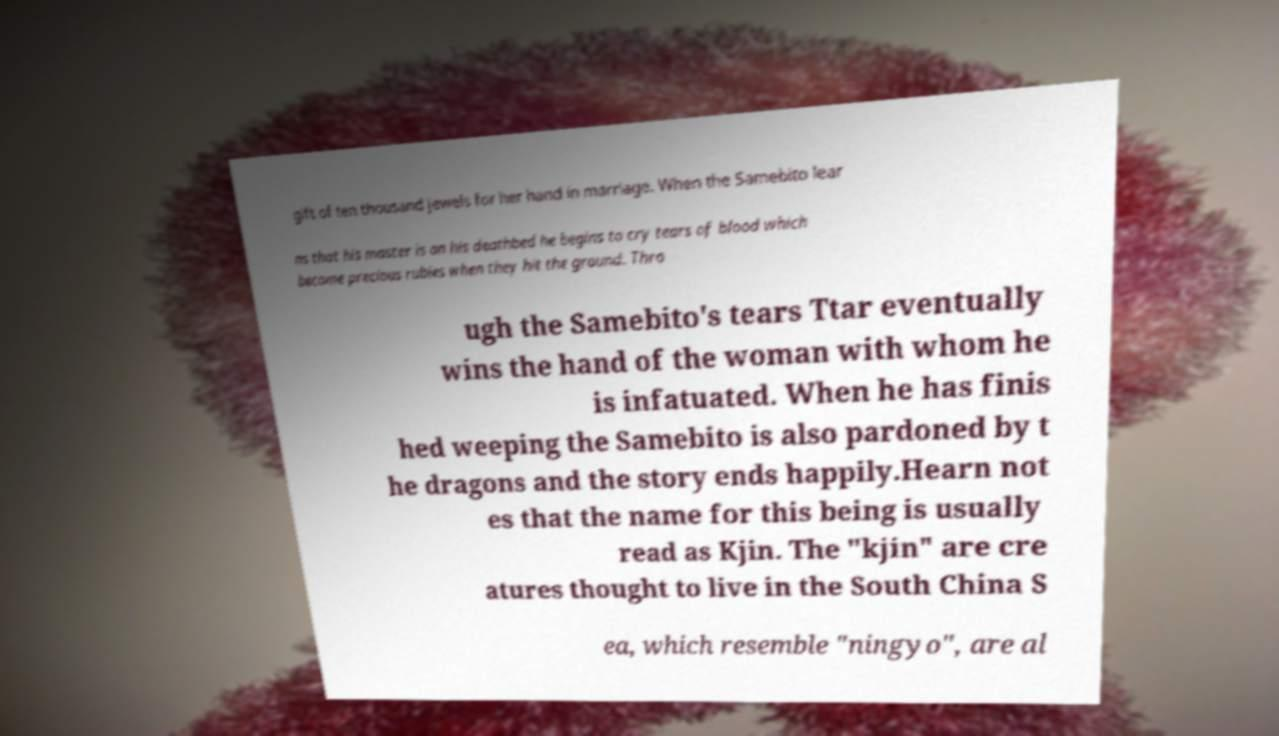Could you extract and type out the text from this image? gift of ten thousand jewels for her hand in marriage. When the Samebito lear ns that his master is on his deathbed he begins to cry tears of blood which become precious rubies when they hit the ground. Thro ugh the Samebito's tears Ttar eventually wins the hand of the woman with whom he is infatuated. When he has finis hed weeping the Samebito is also pardoned by t he dragons and the story ends happily.Hearn not es that the name for this being is usually read as Kjin. The "kjin" are cre atures thought to live in the South China S ea, which resemble "ningyo", are al 